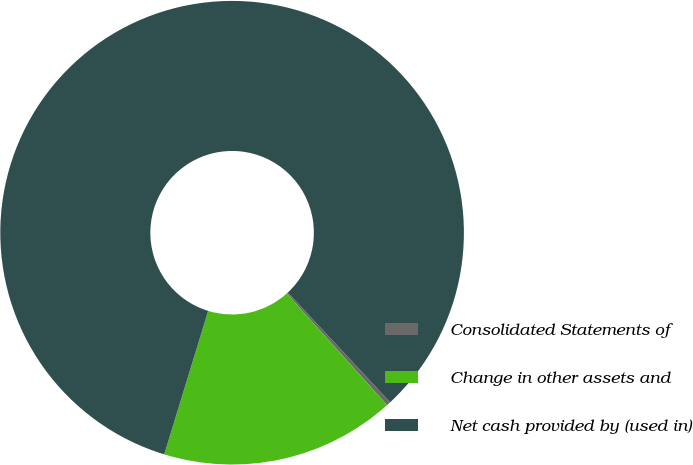Convert chart. <chart><loc_0><loc_0><loc_500><loc_500><pie_chart><fcel>Consolidated Statements of<fcel>Change in other assets and<fcel>Net cash provided by (used in)<nl><fcel>0.29%<fcel>16.38%<fcel>83.33%<nl></chart> 